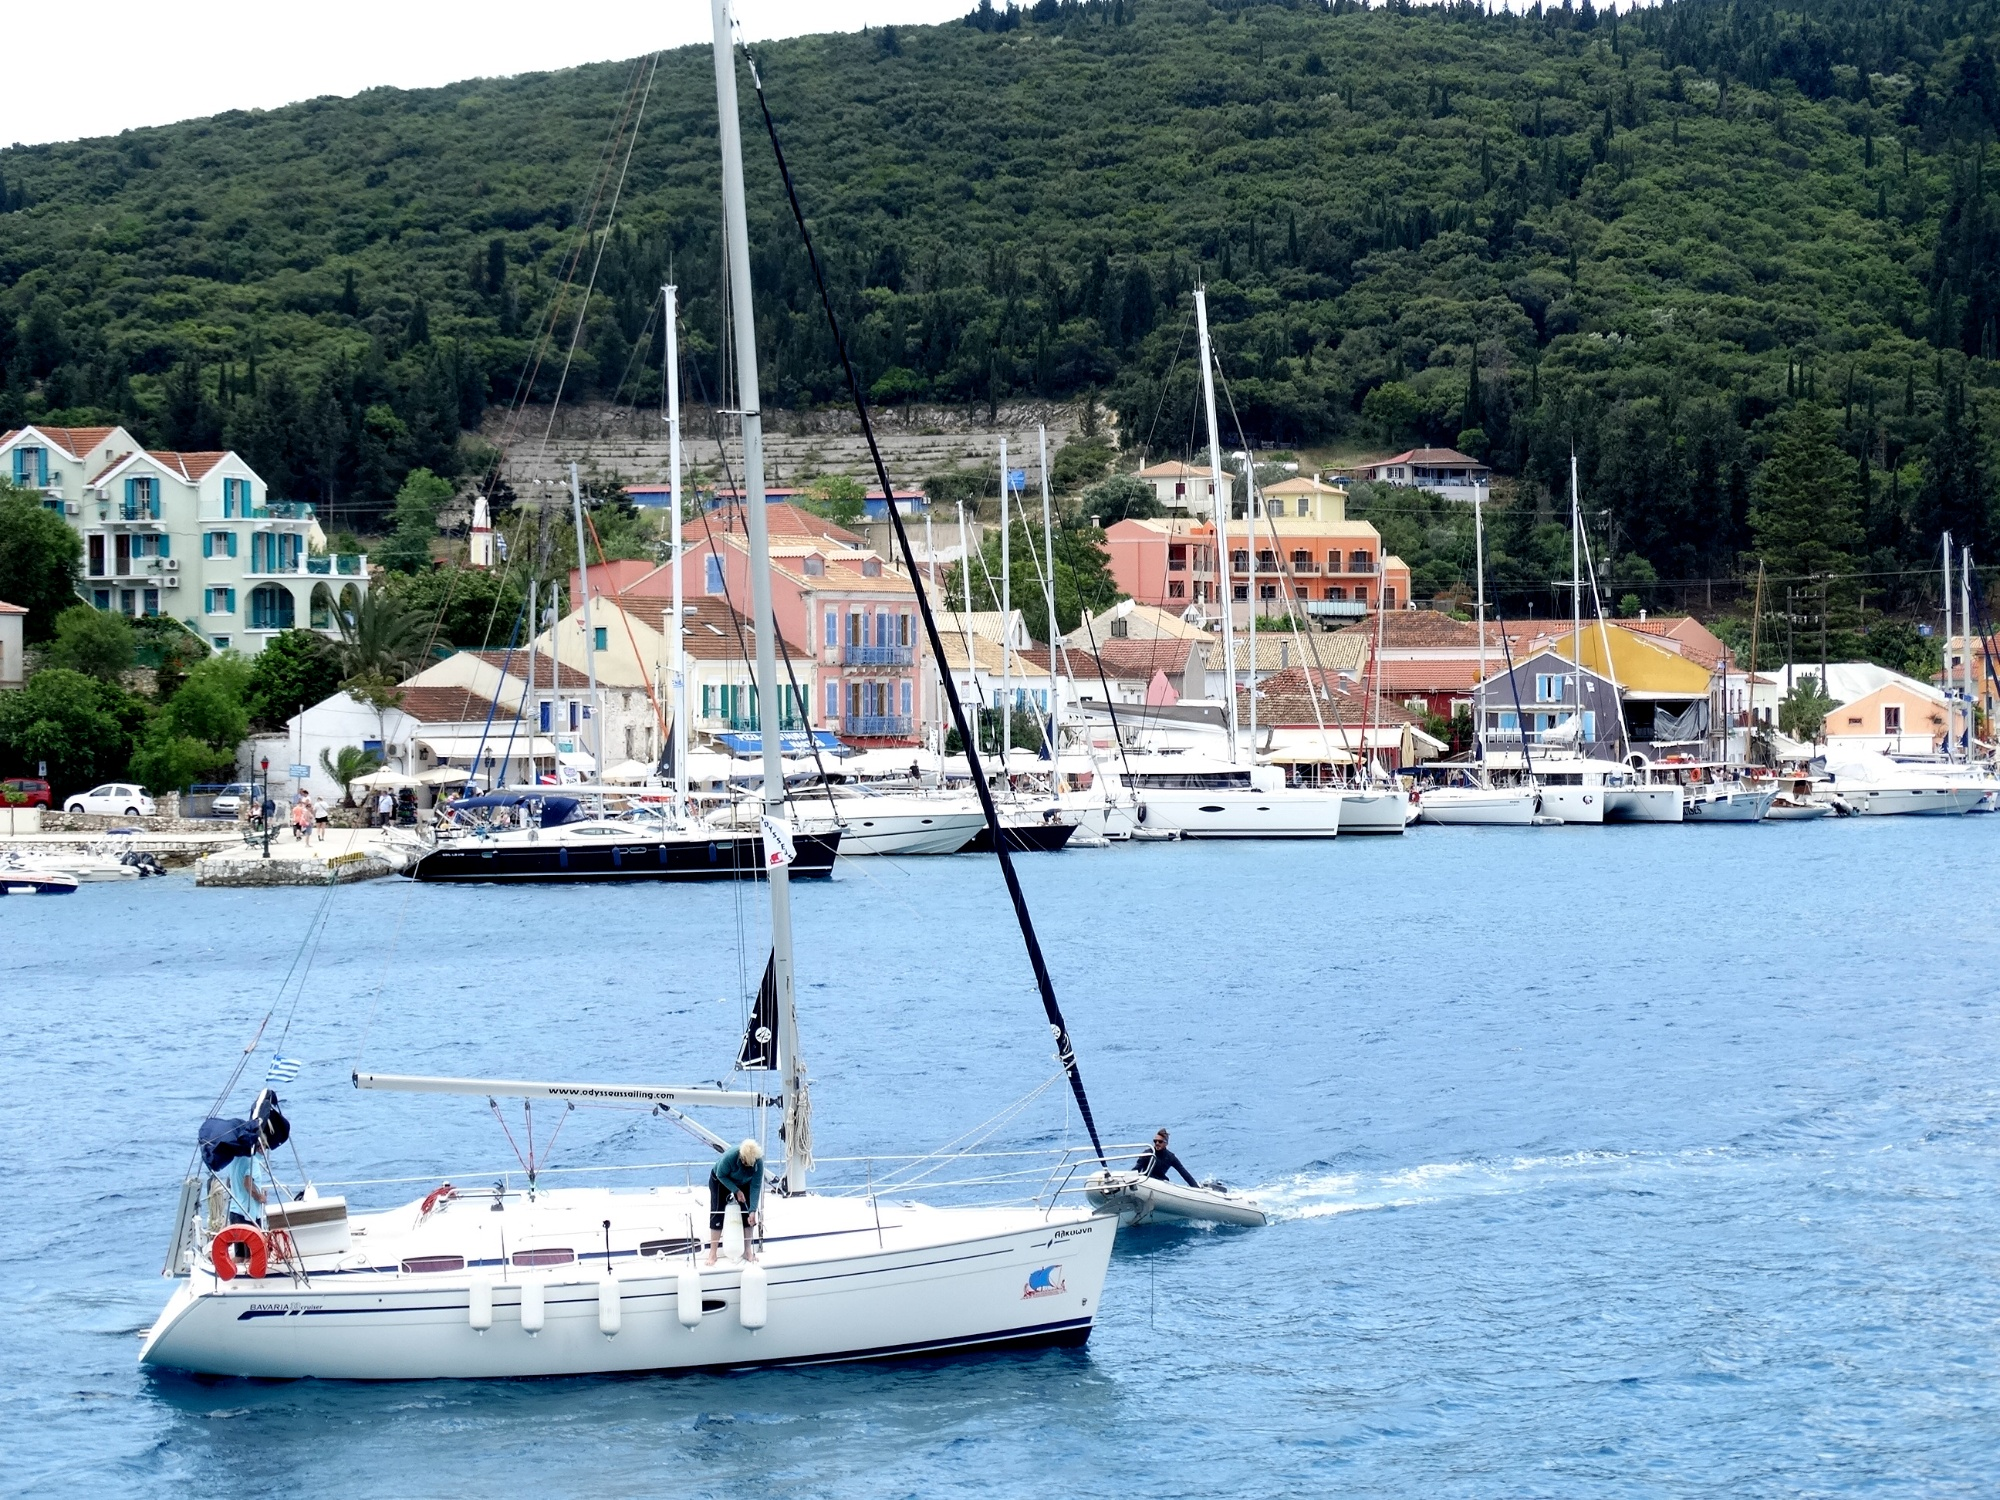Analyze the image in a comprehensive and detailed manner.
 The image captures a serene scene of a sailboat resting in the harbor of a Mediterranean town. The sailboat, painted white with a distinguishing blue stripe, stands tall with its mast piercing the overcast sky. The deep blue water of the harbor reflects the boat and the colorful buildings of the town that are built on a hillside. The town is a vibrant mix of colors, providing a stark contrast to the green trees that dot the hillside. Other boats can be seen in the background, adding to the charm of this coastal town. The overcast sky casts a soft light over the entire scene, enhancing the tranquility of the moment. The landmark identifier "sa_15938" doesn't provide any additional information about the location of this landmark in my current knowledge. However, the Mediterranean setting and the unique architecture of the town might be indicative of its geographical location. 